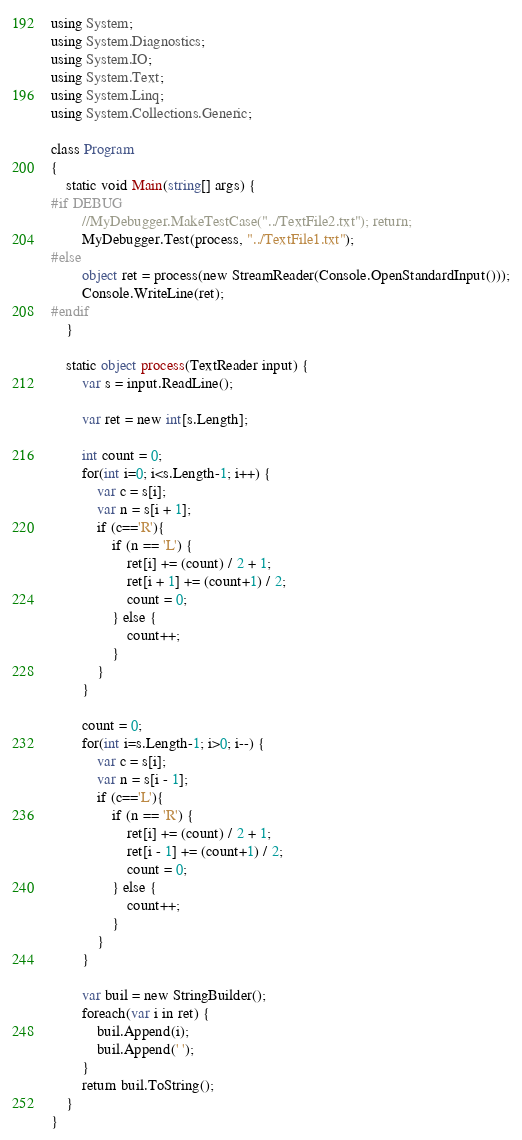Convert code to text. <code><loc_0><loc_0><loc_500><loc_500><_C#_>using System;
using System.Diagnostics;
using System.IO;
using System.Text;
using System.Linq;
using System.Collections.Generic;

class Program
{
    static void Main(string[] args) {
#if DEBUG
        //MyDebugger.MakeTestCase("../TextFile2.txt"); return;
        MyDebugger.Test(process, "../TextFile1.txt");
#else
        object ret = process(new StreamReader(Console.OpenStandardInput()));
        Console.WriteLine(ret);
#endif
    }

    static object process(TextReader input) {
        var s = input.ReadLine();

        var ret = new int[s.Length];

        int count = 0;
        for(int i=0; i<s.Length-1; i++) {
            var c = s[i];
            var n = s[i + 1];
            if (c=='R'){
                if (n == 'L') {
                    ret[i] += (count) / 2 + 1;
                    ret[i + 1] += (count+1) / 2;
                    count = 0;
                } else {
                    count++;
                }
            }
        }
        
        count = 0;
        for(int i=s.Length-1; i>0; i--) {
            var c = s[i];
            var n = s[i - 1];
            if (c=='L'){
                if (n == 'R') {
                    ret[i] += (count) / 2 + 1;
                    ret[i - 1] += (count+1) / 2;
                    count = 0;
                } else {
                    count++;
                }
            }
        }

        var buil = new StringBuilder();
        foreach(var i in ret) {
            buil.Append(i);
            buil.Append(' ');
        }
        return buil.ToString();
    }
}
</code> 